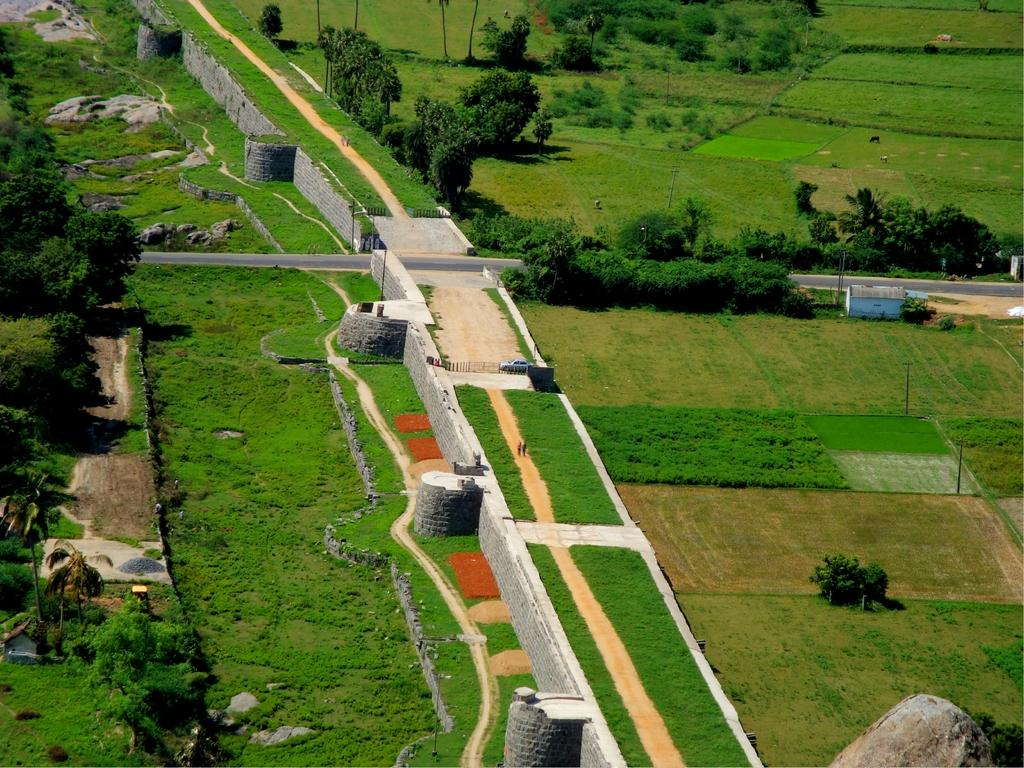What type of view is shown in the image? The image is an aerial view of an area. What natural elements can be seen in the area? There are trees and grass in the area. What man-made structures are present in the area? There is a road, a wall, and a walkway in the area. What types of transportation are visible in the area? There are vehicles in the area. Are there any people present in the image? Yes, there are persons walking through a walkway in the area. How many eggs are being printed on the wall in the image? There are no eggs or printing activity present in the image. 